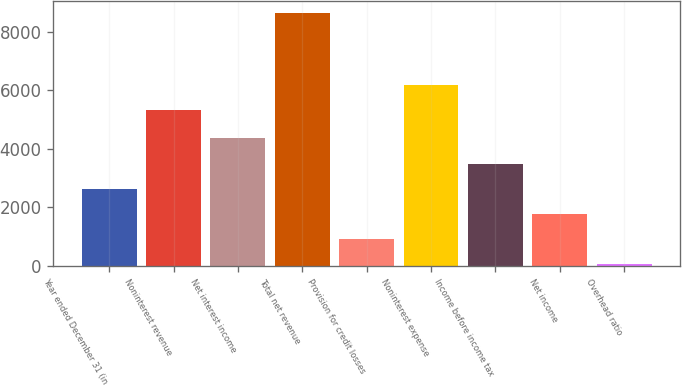<chart> <loc_0><loc_0><loc_500><loc_500><bar_chart><fcel>Year ended December 31 (in<fcel>Noninterest revenue<fcel>Net interest income<fcel>Total net revenue<fcel>Provision for credit losses<fcel>Noninterest expense<fcel>Income before income tax<fcel>Net income<fcel>Overhead ratio<nl><fcel>2635.1<fcel>5321<fcel>4348.5<fcel>8632<fcel>921.7<fcel>6177.7<fcel>3491.8<fcel>1778.4<fcel>65<nl></chart> 